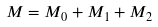Convert formula to latex. <formula><loc_0><loc_0><loc_500><loc_500>M = M _ { 0 } + M _ { 1 } + M _ { 2 }</formula> 